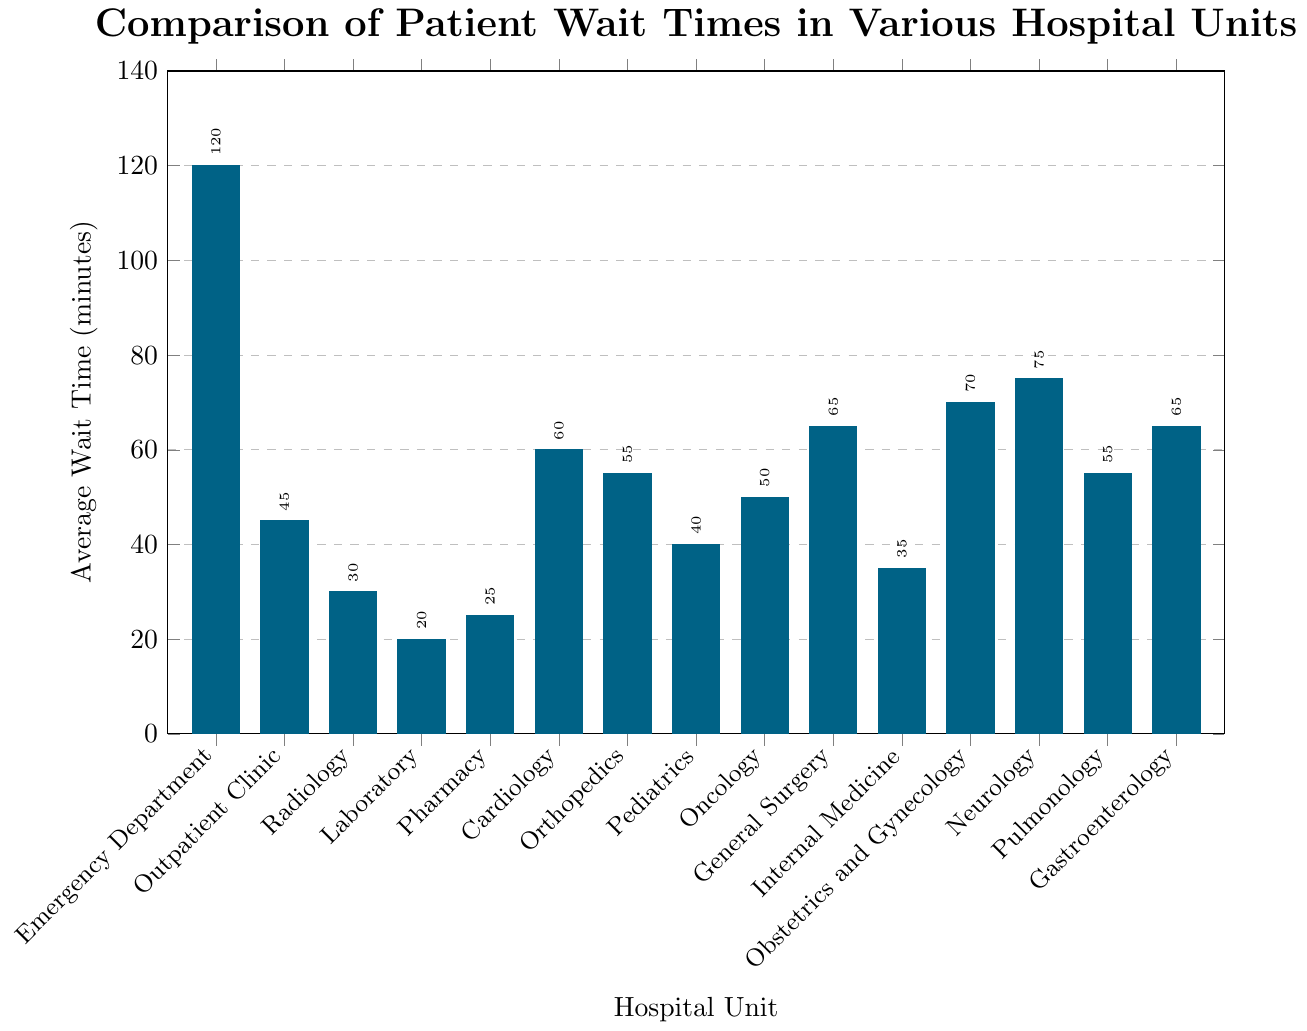What is the hospital unit with the highest average wait time? The highest bar on the chart represents the hospital unit with the highest average wait time. The Emergency Department has the highest bar, indicating an average wait time of 120 minutes.
Answer: Emergency Department What is the average wait time for Oncology? Locate the bar labeled Oncology and read the value at the top of the bar. The average wait time for Oncology is 50 minutes.
Answer: 50 minutes Which unit has a shorter wait time, Cardiology or Obstetrics and Gynecology? Compare the heights of the bars labeled Cardiology and Obstetrics and Gynecology. Cardiology has a wait time of 60 minutes, while Obstetrics and Gynecology has a wait time of 70 minutes.
Answer: Cardiology What is the difference in average wait time between Internal Medicine and Neurology? Locate the bars for Internal Medicine and Neurology. Internal Medicine has a wait time of 35 minutes, while Neurology has a wait time of 75 minutes. Subtract 35 from 75 to get the difference.
Answer: 40 minutes Which units have an average wait time less than 30 minutes? Identify the bars whose heights are below the 30-minute mark. These units are Radiology (30 minutes), Laboratory (20 minutes), and Pharmacy (25 minutes).
Answer: Radiology, Laboratory, Pharmacy What is the combined average wait time for General Surgery and Gastroenterology? Locate the bars for General Surgery and Gastroenterology. General Surgery has a wait time of 65 minutes and Gastroenterology also has a wait time of 65 minutes. Add these two values together: 65 + 65.
Answer: 130 minutes Rank the top three units with the longest wait times. Identify the three highest bars on the chart. They are Emergency Department (120 minutes), Neurology (75 minutes), and Obstetrics and Gynecology (70 minutes). Rank them accordingly.
Answer: Emergency Department, Neurology, Obstetrics and Gynecology What is the median wait time across all listed hospital units? First, list all the wait times in ascending order: 20, 25, 30, 35, 40, 45, 50, 55, 55, 60, 65, 65, 70, 75, 120. Since there are 15 values, the median is the 8th number in this ordered list: 55 minutes.
Answer: 55 minutes Among Pediatrics and Oncology, which unit has the lower average wait time? Compare the bars for Pediatrics and Oncology. Pediatrics has an average wait time of 40 minutes, while Oncology has an average wait time of 50 minutes.
Answer: Pediatrics 